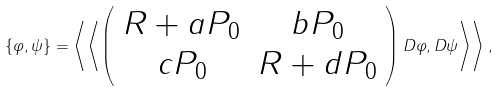Convert formula to latex. <formula><loc_0><loc_0><loc_500><loc_500>\left \{ \varphi , \psi \right \} = \left \langle \left \langle \left ( \begin{array} { c c } R + a P _ { 0 } & b P _ { 0 } \\ c P _ { 0 } & R + d P _ { 0 } \end{array} \right ) D \varphi , D \psi \right \rangle \right \rangle ,</formula> 